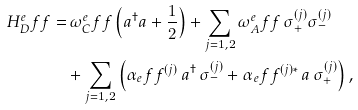Convert formula to latex. <formula><loc_0><loc_0><loc_500><loc_500>H _ { D } ^ { e } f f = & \, \omega _ { C } ^ { e } f f \left ( a ^ { \dag } a + \frac { 1 } { 2 } \right ) + \sum _ { j = 1 , 2 } \omega _ { A } ^ { e } f f \, \sigma _ { + } ^ { ( j ) } \sigma _ { - } ^ { ( j ) } \\ & + \sum _ { j = 1 , 2 } \left ( \alpha _ { e } f f ^ { ( j ) } \, a ^ { \dag } \, \sigma _ { - } ^ { ( j ) } + \alpha _ { e } f f ^ { ( j ) * } \, a \, \sigma _ { + } ^ { ( j ) } \right ) ,</formula> 